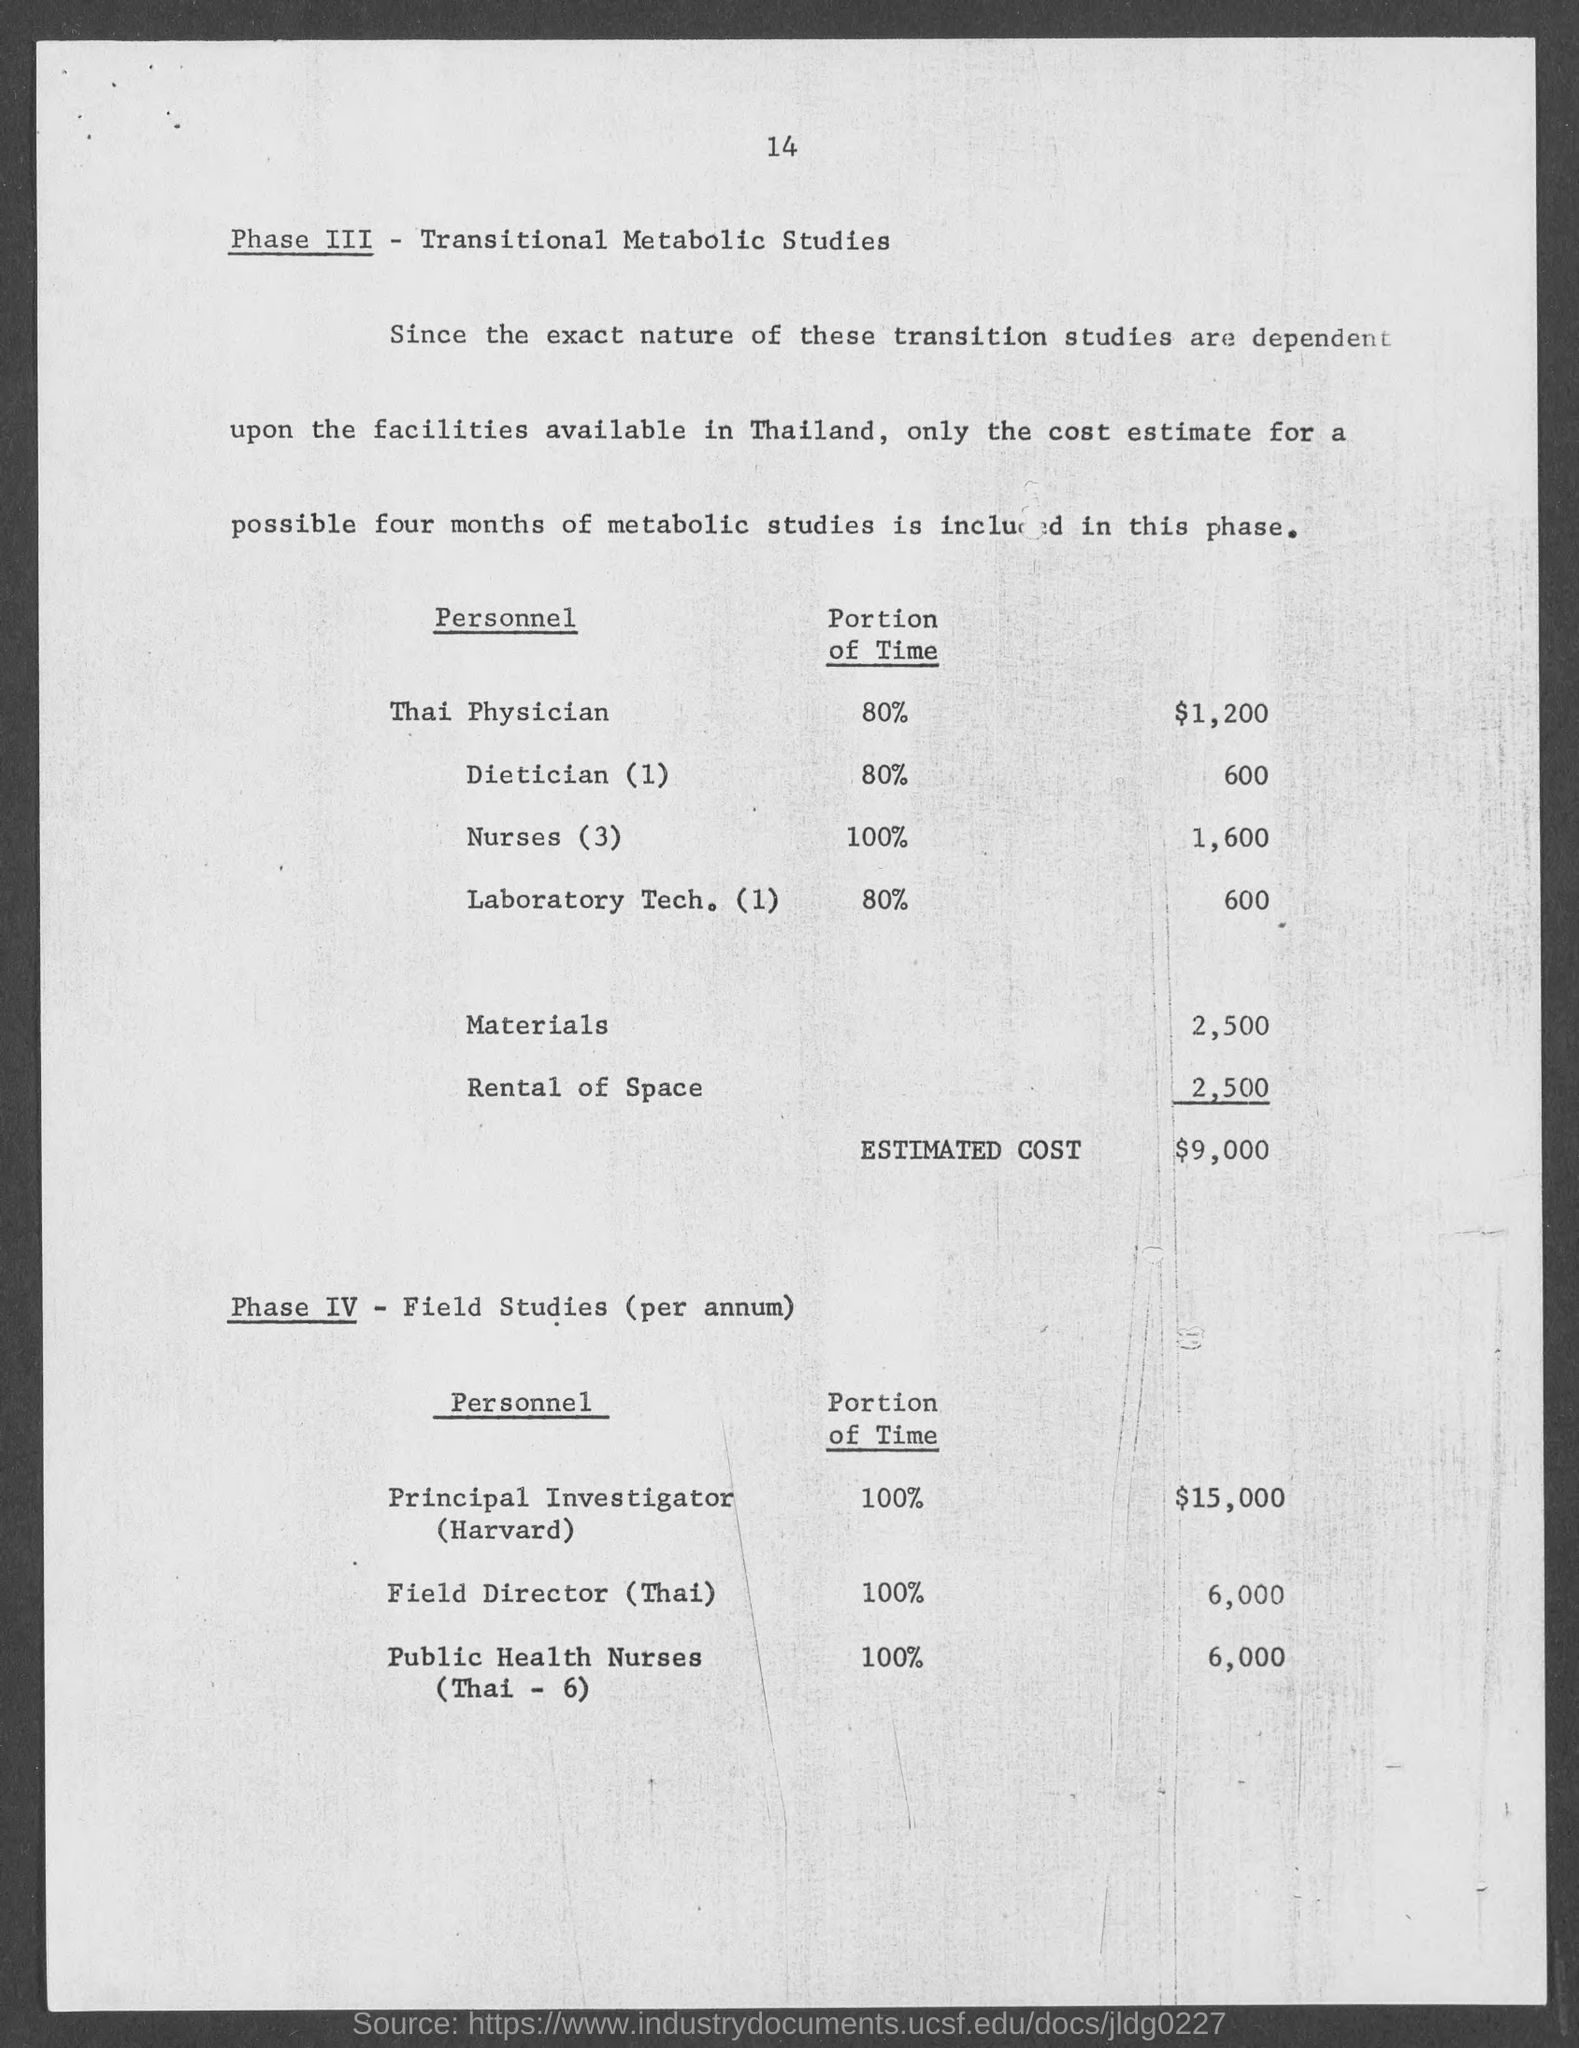What portion of the time is dedicated by the Thai Physician as per the document?
 80% 